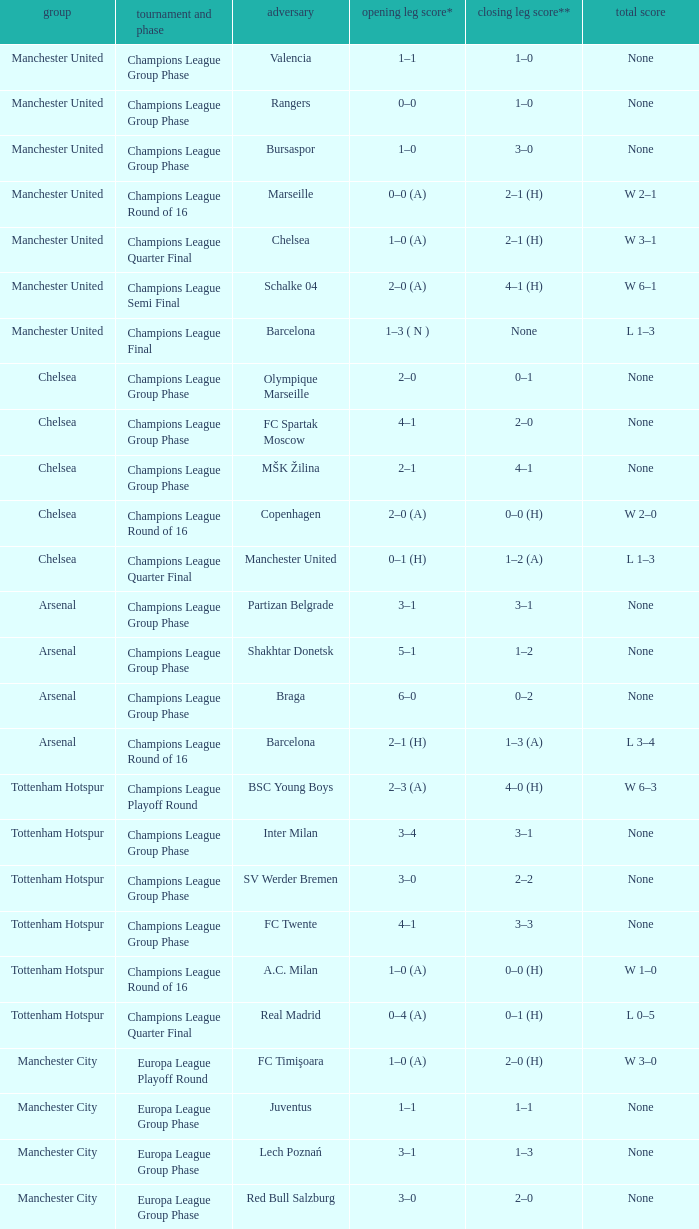How many goals did each team score in the first leg of the match between Liverpool and Steaua Bucureşti? 4–1. 